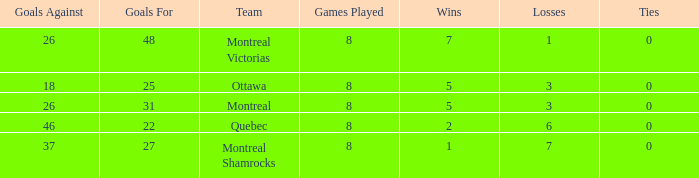For teams with fewer than 5 wins, goals against over 37, and fewer than 8 games played, what is the average number of ties? None. 